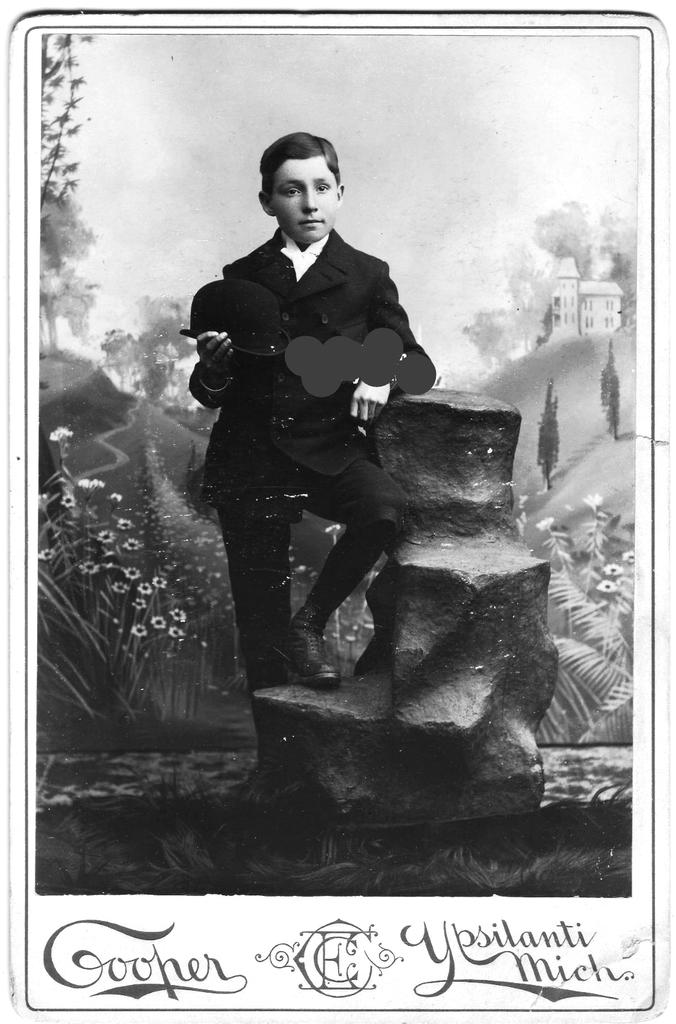What is the main subject of the poster in the image? The poster depicts a person standing with the support of a rock. What other elements can be seen in the image besides the poster? There are flowers and plants visible in the image. How many oranges are being held by the person in the poster? There are no oranges visible in the image, as the poster depicts a person standing with the support of a rock. What trick is the person in the poster performing with their hands? There is no trick being performed by the person in the poster; they are simply standing with the support of a rock. 